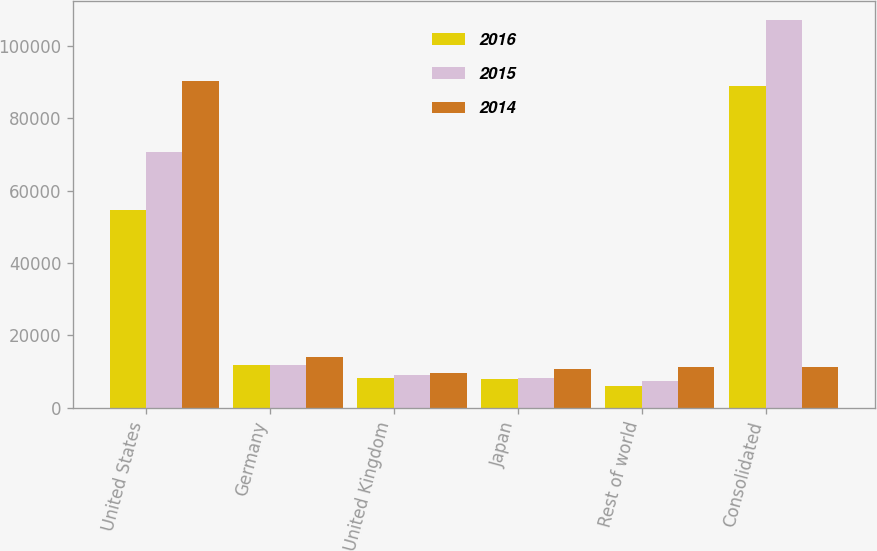Convert chart. <chart><loc_0><loc_0><loc_500><loc_500><stacked_bar_chart><ecel><fcel>United States<fcel>Germany<fcel>United Kingdom<fcel>Japan<fcel>Rest of world<fcel>Consolidated<nl><fcel>2016<fcel>54717<fcel>11919<fcel>8341<fcel>7912<fcel>6099<fcel>88988<nl><fcel>2015<fcel>70537<fcel>11816<fcel>9033<fcel>8264<fcel>7356<fcel>107006<nl><fcel>2014<fcel>90349<fcel>14148<fcel>9547<fcel>10797<fcel>11146<fcel>11146<nl></chart> 